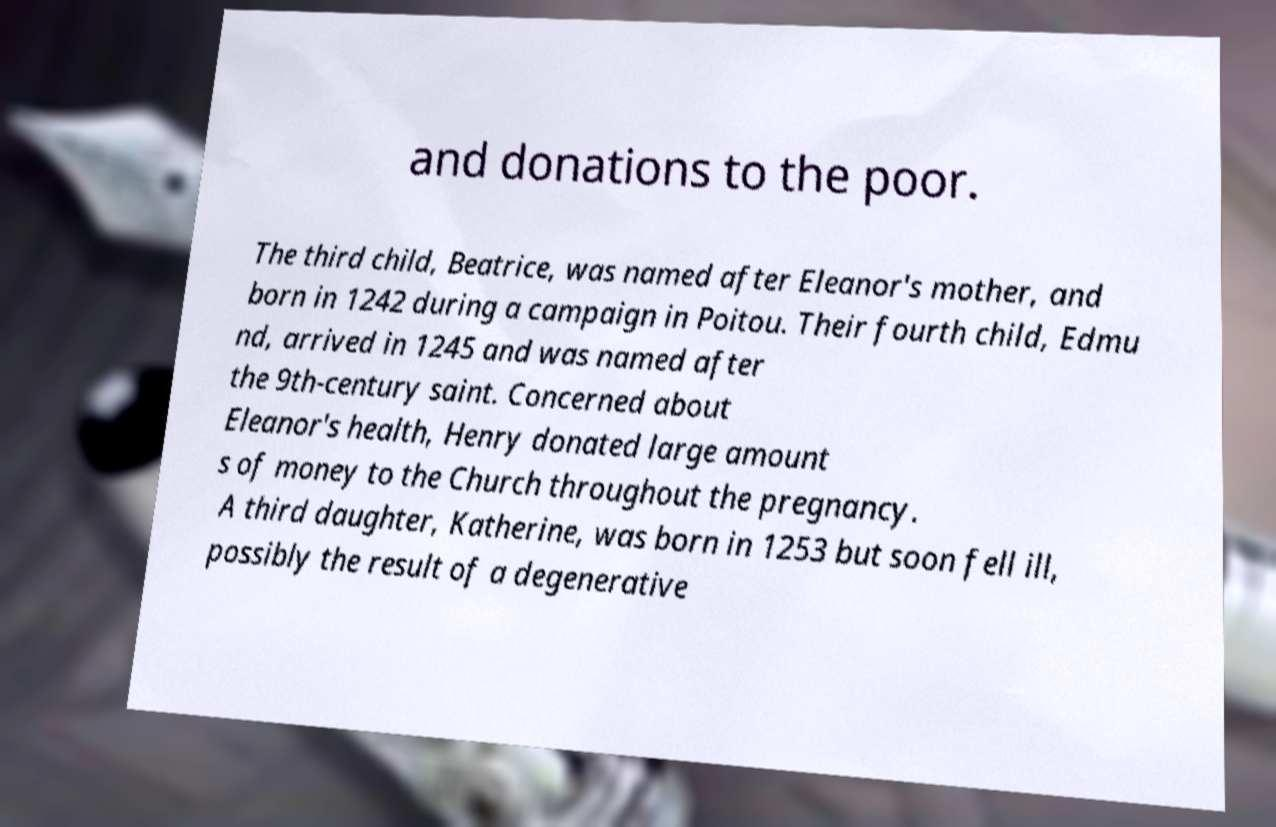For documentation purposes, I need the text within this image transcribed. Could you provide that? and donations to the poor. The third child, Beatrice, was named after Eleanor's mother, and born in 1242 during a campaign in Poitou. Their fourth child, Edmu nd, arrived in 1245 and was named after the 9th-century saint. Concerned about Eleanor's health, Henry donated large amount s of money to the Church throughout the pregnancy. A third daughter, Katherine, was born in 1253 but soon fell ill, possibly the result of a degenerative 